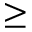Convert formula to latex. <formula><loc_0><loc_0><loc_500><loc_500>\geq</formula> 